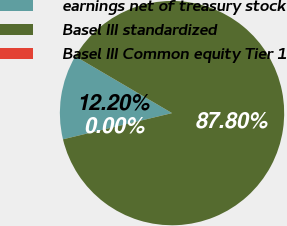Convert chart. <chart><loc_0><loc_0><loc_500><loc_500><pie_chart><fcel>earnings net of treasury stock<fcel>Basel III standardized<fcel>Basel III Common equity Tier 1<nl><fcel>12.2%<fcel>87.79%<fcel>0.0%<nl></chart> 